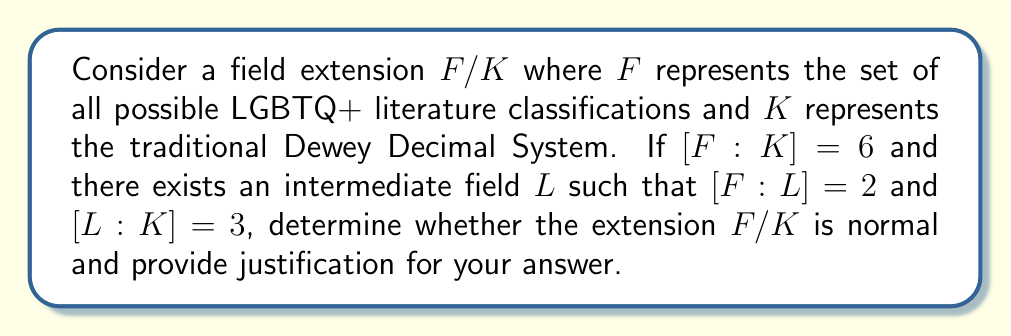Teach me how to tackle this problem. Let's approach this step-by-step:

1) First, recall that for a field extension $F/K$ to be normal, every irreducible polynomial over $K$ that has at least one root in $F$ must factor completely over $F$.

2) We're given that $[F:K] = 6$, $[F:L] = 2$, and $[L:K] = 3$. This satisfies the multiplicative property of field extensions:
   
   $[F:K] = [F:L] \cdot [L:K] = 2 \cdot 3 = 6$

3) The fact that there exists an intermediate field $L$ such that $[F:L] = 2$ implies that $F/L$ is a quadratic extension. This means there exists an element $\alpha \in F$ such that $F = L(\alpha)$ and $\alpha$ is a root of an irreducible quadratic polynomial over $L$.

4) Similarly, $L/K$ being a cubic extension implies there exists $\beta \in L$ such that $L = K(\beta)$ and $\beta$ is a root of an irreducible cubic polynomial over $K$.

5) Now, consider the minimal polynomial of $\alpha$ over $K$, let's call it $f(x)$. We know that:
   
   $\deg(f) = [F:K] = 6$

6) If $F/K$ were normal, $f(x)$ would need to split completely in $F$. However, we can't guarantee this based on the given information.

7) In fact, the structure of the extension suggests that $f(x)$ might not split completely in $F$. The existence of the intermediate field $L$ implies that $f(x)$ factors as the product of three irreducible quadratic polynomials over $L$, but not necessarily over $K$.

8) Therefore, we cannot conclude that $F/K$ is normal based on the given information.
Answer: The extension $F/K$ is not necessarily normal. 